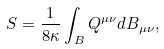<formula> <loc_0><loc_0><loc_500><loc_500>S = \frac { 1 } { 8 \kappa } \int _ { B } Q ^ { \mu \nu } d B _ { \mu \nu } ,</formula> 